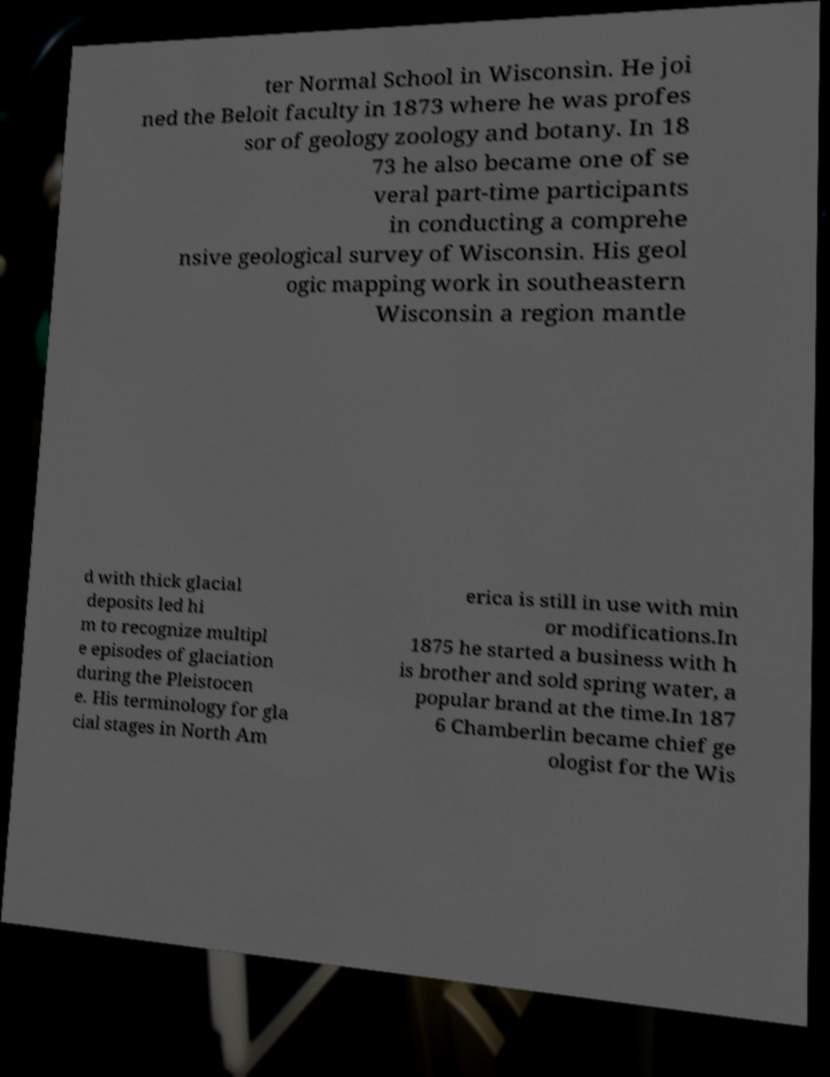What messages or text are displayed in this image? I need them in a readable, typed format. ter Normal School in Wisconsin. He joi ned the Beloit faculty in 1873 where he was profes sor of geology zoology and botany. In 18 73 he also became one of se veral part-time participants in conducting a comprehe nsive geological survey of Wisconsin. His geol ogic mapping work in southeastern Wisconsin a region mantle d with thick glacial deposits led hi m to recognize multipl e episodes of glaciation during the Pleistocen e. His terminology for gla cial stages in North Am erica is still in use with min or modifications.In 1875 he started a business with h is brother and sold spring water, a popular brand at the time.In 187 6 Chamberlin became chief ge ologist for the Wis 